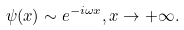<formula> <loc_0><loc_0><loc_500><loc_500>\psi ( x ) \sim e ^ { - i \omega x } , x \rightarrow + \infty .</formula> 